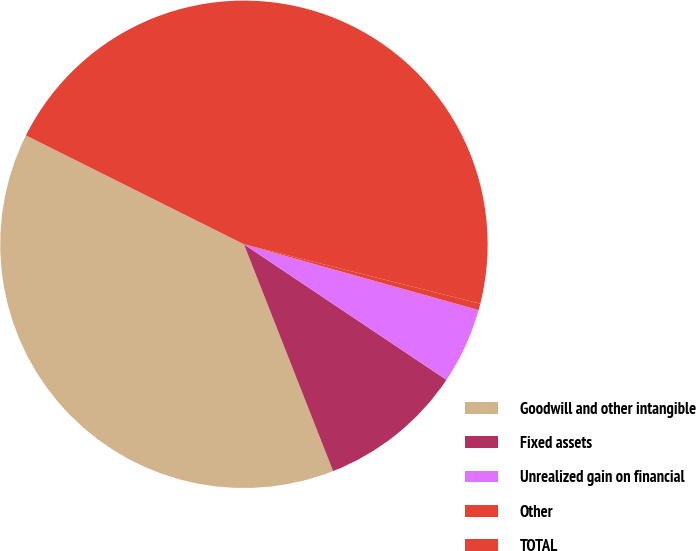Convert chart. <chart><loc_0><loc_0><loc_500><loc_500><pie_chart><fcel>Goodwill and other intangible<fcel>Fixed assets<fcel>Unrealized gain on financial<fcel>Other<fcel>TOTAL<nl><fcel>38.34%<fcel>9.65%<fcel>5.04%<fcel>0.43%<fcel>46.55%<nl></chart> 